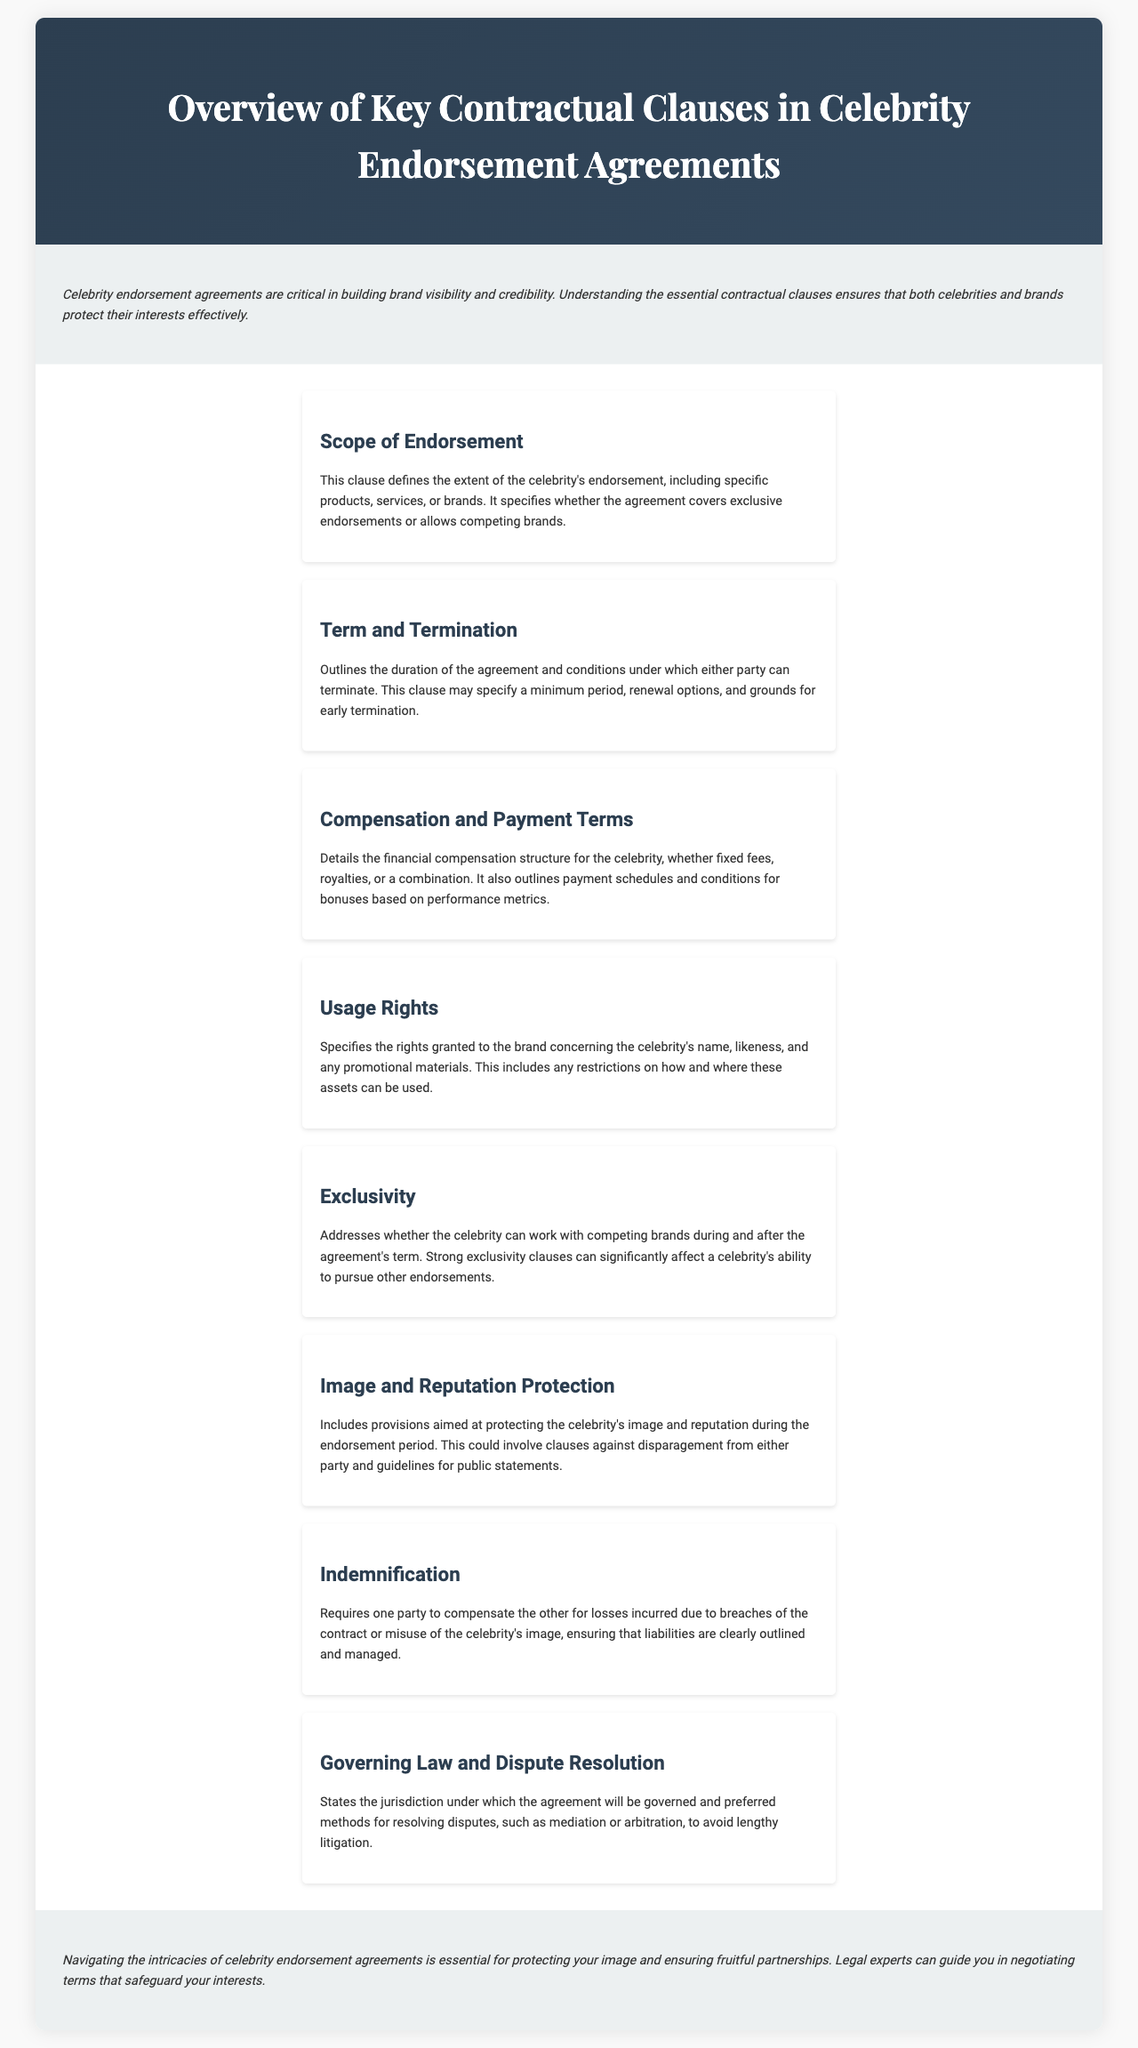What is the main focus of celebrity endorsement agreements? The introduction highlights that celebrity endorsement agreements are critical in building brand visibility and credibility.
Answer: Brand visibility and credibility What clause defines the extent of the celebrity's endorsement? The section discussing key clauses mentions the "Scope of Endorsement" clause, which details the endorsement's extent.
Answer: Scope of Endorsement What does the "Compensation and Payment Terms" clause cover? The document states that this clause details the financial compensation structure for the celebrity, outlining fees, royalties, and payment schedules.
Answer: Financial compensation structure Which clause protects the celebrity's image? The document specifies the "Image and Reputation Protection" clause addresses the protection of the celebrity's image and reputation.
Answer: Image and Reputation Protection What is addressed by the "Exclusivity" clause? The "Exclusivity" clause discusses whether the celebrity can work with competing brands during and after the agreement's term.
Answer: Competing brands What type of resolution method is mentioned for disputes? The "Governing Law and Dispute Resolution" clause refers to preferred methods for resolving disputes, such as mediation or arbitration.
Answer: Mediation or arbitration Which clause requires compensation for losses due to contract breaches? The "Indemnification" clause requires one party to compensate the other for losses incurred from breaches of the contract.
Answer: Indemnification What is the purpose of the introduction in the brochure? The introduction aims to emphasize the importance of understanding essential contractual clauses in celebrity endorsement agreements.
Answer: Understanding essential contractual clauses 